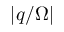Convert formula to latex. <formula><loc_0><loc_0><loc_500><loc_500>| q / \Omega |</formula> 